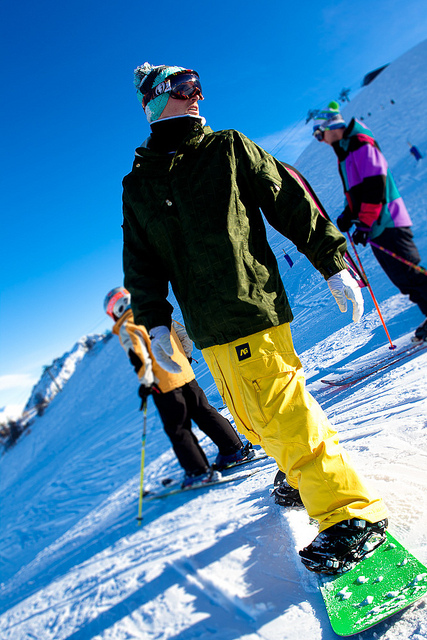Identify the text contained in this image. as 